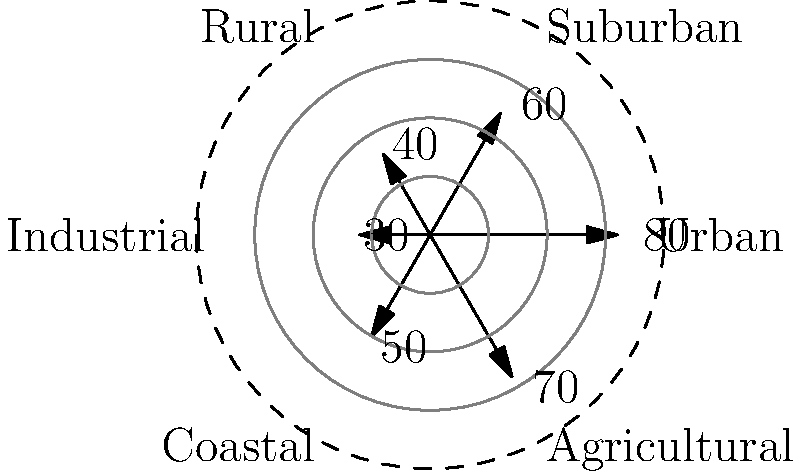In your recent campaign, you've conducted a large-scale rally to gauge voter support across different regions. The polar coordinate plot above represents the distribution of potential voters (in thousands) who attended your rally from various areas. Which region shows the highest turnout, and how might this information influence your traditional campaign strategy moving forward? To answer this question, we need to analyze the polar coordinate plot:

1. The plot is divided into six sectors, each representing a different region:
   Urban, Suburban, Rural, Industrial, Coastal, and Agricultural.

2. The distance from the center represents the number of potential voters (in thousands) from each region.

3. To find the highest turnout, we compare the values:
   Urban: 80
   Suburban: 60
   Rural: 40
   Industrial: 30
   Coastal: 50
   Agricultural: 70

4. The highest value is 80, corresponding to the Urban region.

5. This information can influence the traditional campaign strategy by:
   a) Focusing more resources on urban areas to capitalize on the strong support.
   b) Considering the effectiveness of large-scale rallies in urban settings.
   c) Tailoring campaign messages to address urban issues and concerns.
   d) Potentially organizing more rallies in urban areas to maintain momentum.
   e) Using the urban support as a model to boost turnout in other regions.
Answer: Urban region (80,000 voters); intensify urban campaigning while adapting strategies for other areas. 